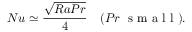Convert formula to latex. <formula><loc_0><loc_0><loc_500><loc_500>N u \simeq \frac { \sqrt { R a P r } } { 4 } \quad ( P r \ s m a l l ) .</formula> 